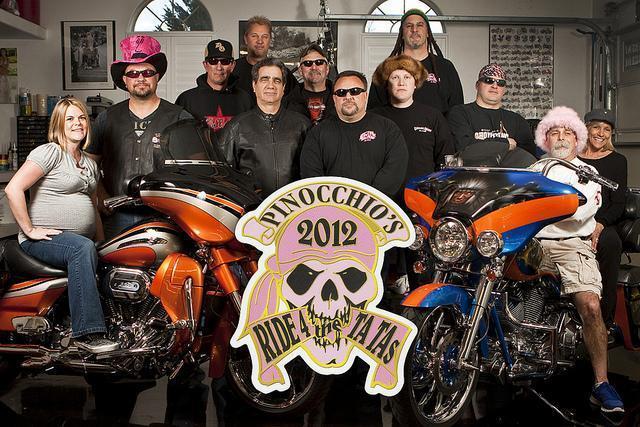How many motorcycles are there?
Give a very brief answer. 2. How many people are there?
Give a very brief answer. 11. How many skateboard wheels are red?
Give a very brief answer. 0. 